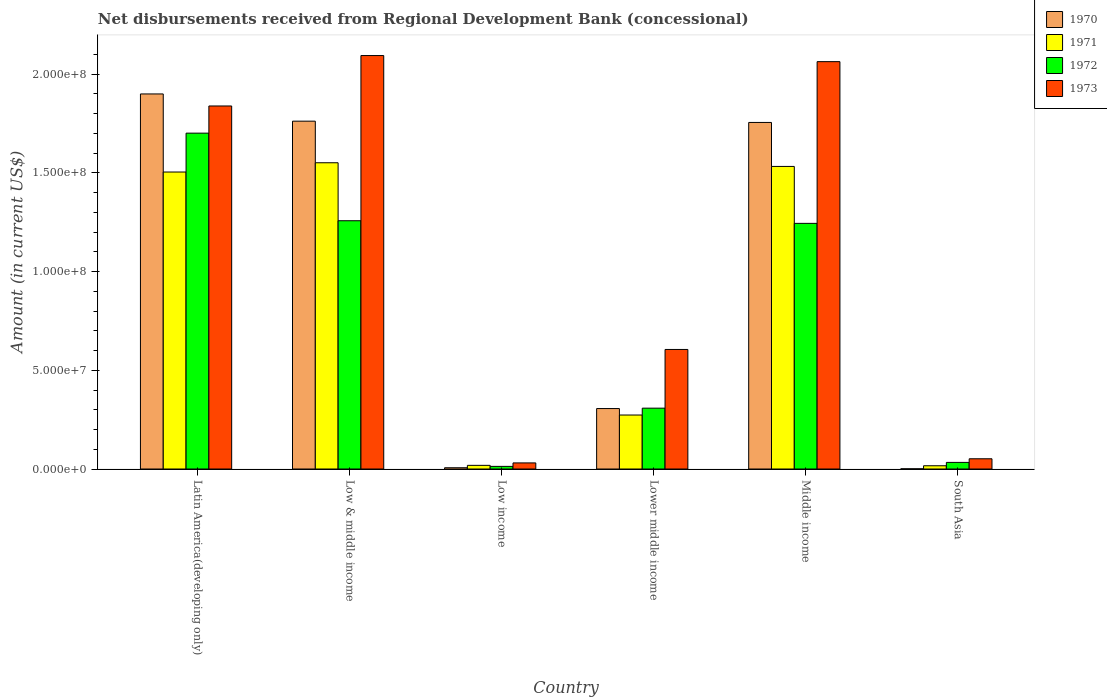How many different coloured bars are there?
Provide a succinct answer. 4. How many groups of bars are there?
Your response must be concise. 6. Are the number of bars per tick equal to the number of legend labels?
Your response must be concise. Yes. How many bars are there on the 6th tick from the left?
Keep it short and to the point. 4. How many bars are there on the 1st tick from the right?
Offer a very short reply. 4. What is the label of the 3rd group of bars from the left?
Offer a very short reply. Low income. In how many cases, is the number of bars for a given country not equal to the number of legend labels?
Ensure brevity in your answer.  0. What is the amount of disbursements received from Regional Development Bank in 1970 in Low income?
Keep it short and to the point. 6.47e+05. Across all countries, what is the maximum amount of disbursements received from Regional Development Bank in 1972?
Make the answer very short. 1.70e+08. Across all countries, what is the minimum amount of disbursements received from Regional Development Bank in 1970?
Your answer should be compact. 1.09e+05. In which country was the amount of disbursements received from Regional Development Bank in 1970 maximum?
Keep it short and to the point. Latin America(developing only). In which country was the amount of disbursements received from Regional Development Bank in 1972 minimum?
Your answer should be very brief. Low income. What is the total amount of disbursements received from Regional Development Bank in 1973 in the graph?
Keep it short and to the point. 6.69e+08. What is the difference between the amount of disbursements received from Regional Development Bank in 1972 in Latin America(developing only) and that in South Asia?
Provide a succinct answer. 1.67e+08. What is the difference between the amount of disbursements received from Regional Development Bank in 1970 in Middle income and the amount of disbursements received from Regional Development Bank in 1971 in Lower middle income?
Ensure brevity in your answer.  1.48e+08. What is the average amount of disbursements received from Regional Development Bank in 1970 per country?
Ensure brevity in your answer.  9.55e+07. What is the difference between the amount of disbursements received from Regional Development Bank of/in 1971 and amount of disbursements received from Regional Development Bank of/in 1970 in Lower middle income?
Offer a terse response. -3.27e+06. What is the ratio of the amount of disbursements received from Regional Development Bank in 1970 in Low income to that in South Asia?
Your answer should be compact. 5.94. Is the amount of disbursements received from Regional Development Bank in 1972 in Latin America(developing only) less than that in Low income?
Provide a short and direct response. No. What is the difference between the highest and the second highest amount of disbursements received from Regional Development Bank in 1972?
Your answer should be compact. 4.44e+07. What is the difference between the highest and the lowest amount of disbursements received from Regional Development Bank in 1970?
Your answer should be very brief. 1.90e+08. In how many countries, is the amount of disbursements received from Regional Development Bank in 1971 greater than the average amount of disbursements received from Regional Development Bank in 1971 taken over all countries?
Ensure brevity in your answer.  3. How many bars are there?
Give a very brief answer. 24. What is the difference between two consecutive major ticks on the Y-axis?
Your response must be concise. 5.00e+07. Are the values on the major ticks of Y-axis written in scientific E-notation?
Provide a succinct answer. Yes. Does the graph contain any zero values?
Provide a short and direct response. No. Does the graph contain grids?
Give a very brief answer. No. How are the legend labels stacked?
Make the answer very short. Vertical. What is the title of the graph?
Make the answer very short. Net disbursements received from Regional Development Bank (concessional). Does "2000" appear as one of the legend labels in the graph?
Your answer should be compact. No. What is the label or title of the X-axis?
Give a very brief answer. Country. What is the label or title of the Y-axis?
Give a very brief answer. Amount (in current US$). What is the Amount (in current US$) in 1970 in Latin America(developing only)?
Make the answer very short. 1.90e+08. What is the Amount (in current US$) in 1971 in Latin America(developing only)?
Your response must be concise. 1.50e+08. What is the Amount (in current US$) of 1972 in Latin America(developing only)?
Offer a terse response. 1.70e+08. What is the Amount (in current US$) of 1973 in Latin America(developing only)?
Ensure brevity in your answer.  1.84e+08. What is the Amount (in current US$) in 1970 in Low & middle income?
Offer a very short reply. 1.76e+08. What is the Amount (in current US$) of 1971 in Low & middle income?
Your answer should be very brief. 1.55e+08. What is the Amount (in current US$) of 1972 in Low & middle income?
Provide a succinct answer. 1.26e+08. What is the Amount (in current US$) in 1973 in Low & middle income?
Offer a very short reply. 2.09e+08. What is the Amount (in current US$) of 1970 in Low income?
Ensure brevity in your answer.  6.47e+05. What is the Amount (in current US$) of 1971 in Low income?
Ensure brevity in your answer.  1.86e+06. What is the Amount (in current US$) in 1972 in Low income?
Keep it short and to the point. 1.33e+06. What is the Amount (in current US$) in 1973 in Low income?
Your answer should be very brief. 3.09e+06. What is the Amount (in current US$) in 1970 in Lower middle income?
Offer a very short reply. 3.06e+07. What is the Amount (in current US$) of 1971 in Lower middle income?
Give a very brief answer. 2.74e+07. What is the Amount (in current US$) in 1972 in Lower middle income?
Your answer should be compact. 3.08e+07. What is the Amount (in current US$) in 1973 in Lower middle income?
Provide a short and direct response. 6.06e+07. What is the Amount (in current US$) of 1970 in Middle income?
Make the answer very short. 1.76e+08. What is the Amount (in current US$) of 1971 in Middle income?
Provide a short and direct response. 1.53e+08. What is the Amount (in current US$) of 1972 in Middle income?
Your response must be concise. 1.24e+08. What is the Amount (in current US$) of 1973 in Middle income?
Provide a short and direct response. 2.06e+08. What is the Amount (in current US$) of 1970 in South Asia?
Keep it short and to the point. 1.09e+05. What is the Amount (in current US$) in 1971 in South Asia?
Keep it short and to the point. 1.65e+06. What is the Amount (in current US$) of 1972 in South Asia?
Your response must be concise. 3.35e+06. What is the Amount (in current US$) in 1973 in South Asia?
Provide a succinct answer. 5.18e+06. Across all countries, what is the maximum Amount (in current US$) of 1970?
Provide a succinct answer. 1.90e+08. Across all countries, what is the maximum Amount (in current US$) of 1971?
Give a very brief answer. 1.55e+08. Across all countries, what is the maximum Amount (in current US$) of 1972?
Ensure brevity in your answer.  1.70e+08. Across all countries, what is the maximum Amount (in current US$) of 1973?
Offer a very short reply. 2.09e+08. Across all countries, what is the minimum Amount (in current US$) of 1970?
Your answer should be very brief. 1.09e+05. Across all countries, what is the minimum Amount (in current US$) in 1971?
Make the answer very short. 1.65e+06. Across all countries, what is the minimum Amount (in current US$) in 1972?
Keep it short and to the point. 1.33e+06. Across all countries, what is the minimum Amount (in current US$) in 1973?
Offer a very short reply. 3.09e+06. What is the total Amount (in current US$) of 1970 in the graph?
Ensure brevity in your answer.  5.73e+08. What is the total Amount (in current US$) in 1971 in the graph?
Offer a very short reply. 4.90e+08. What is the total Amount (in current US$) of 1972 in the graph?
Make the answer very short. 4.56e+08. What is the total Amount (in current US$) of 1973 in the graph?
Make the answer very short. 6.69e+08. What is the difference between the Amount (in current US$) in 1970 in Latin America(developing only) and that in Low & middle income?
Your answer should be very brief. 1.38e+07. What is the difference between the Amount (in current US$) in 1971 in Latin America(developing only) and that in Low & middle income?
Ensure brevity in your answer.  -4.69e+06. What is the difference between the Amount (in current US$) in 1972 in Latin America(developing only) and that in Low & middle income?
Ensure brevity in your answer.  4.44e+07. What is the difference between the Amount (in current US$) of 1973 in Latin America(developing only) and that in Low & middle income?
Your response must be concise. -2.55e+07. What is the difference between the Amount (in current US$) in 1970 in Latin America(developing only) and that in Low income?
Your answer should be compact. 1.89e+08. What is the difference between the Amount (in current US$) of 1971 in Latin America(developing only) and that in Low income?
Make the answer very short. 1.49e+08. What is the difference between the Amount (in current US$) in 1972 in Latin America(developing only) and that in Low income?
Your answer should be very brief. 1.69e+08. What is the difference between the Amount (in current US$) of 1973 in Latin America(developing only) and that in Low income?
Your answer should be compact. 1.81e+08. What is the difference between the Amount (in current US$) in 1970 in Latin America(developing only) and that in Lower middle income?
Your response must be concise. 1.59e+08. What is the difference between the Amount (in current US$) of 1971 in Latin America(developing only) and that in Lower middle income?
Offer a terse response. 1.23e+08. What is the difference between the Amount (in current US$) of 1972 in Latin America(developing only) and that in Lower middle income?
Give a very brief answer. 1.39e+08. What is the difference between the Amount (in current US$) of 1973 in Latin America(developing only) and that in Lower middle income?
Offer a very short reply. 1.23e+08. What is the difference between the Amount (in current US$) in 1970 in Latin America(developing only) and that in Middle income?
Give a very brief answer. 1.44e+07. What is the difference between the Amount (in current US$) in 1971 in Latin America(developing only) and that in Middle income?
Provide a short and direct response. -2.84e+06. What is the difference between the Amount (in current US$) of 1972 in Latin America(developing only) and that in Middle income?
Keep it short and to the point. 4.57e+07. What is the difference between the Amount (in current US$) in 1973 in Latin America(developing only) and that in Middle income?
Your answer should be compact. -2.25e+07. What is the difference between the Amount (in current US$) of 1970 in Latin America(developing only) and that in South Asia?
Give a very brief answer. 1.90e+08. What is the difference between the Amount (in current US$) in 1971 in Latin America(developing only) and that in South Asia?
Give a very brief answer. 1.49e+08. What is the difference between the Amount (in current US$) of 1972 in Latin America(developing only) and that in South Asia?
Give a very brief answer. 1.67e+08. What is the difference between the Amount (in current US$) in 1973 in Latin America(developing only) and that in South Asia?
Keep it short and to the point. 1.79e+08. What is the difference between the Amount (in current US$) of 1970 in Low & middle income and that in Low income?
Provide a succinct answer. 1.76e+08. What is the difference between the Amount (in current US$) of 1971 in Low & middle income and that in Low income?
Your response must be concise. 1.53e+08. What is the difference between the Amount (in current US$) of 1972 in Low & middle income and that in Low income?
Keep it short and to the point. 1.24e+08. What is the difference between the Amount (in current US$) of 1973 in Low & middle income and that in Low income?
Keep it short and to the point. 2.06e+08. What is the difference between the Amount (in current US$) of 1970 in Low & middle income and that in Lower middle income?
Offer a terse response. 1.46e+08. What is the difference between the Amount (in current US$) in 1971 in Low & middle income and that in Lower middle income?
Your answer should be compact. 1.28e+08. What is the difference between the Amount (in current US$) in 1972 in Low & middle income and that in Lower middle income?
Provide a succinct answer. 9.49e+07. What is the difference between the Amount (in current US$) in 1973 in Low & middle income and that in Lower middle income?
Ensure brevity in your answer.  1.49e+08. What is the difference between the Amount (in current US$) in 1970 in Low & middle income and that in Middle income?
Offer a very short reply. 6.47e+05. What is the difference between the Amount (in current US$) in 1971 in Low & middle income and that in Middle income?
Your response must be concise. 1.86e+06. What is the difference between the Amount (in current US$) in 1972 in Low & middle income and that in Middle income?
Keep it short and to the point. 1.33e+06. What is the difference between the Amount (in current US$) in 1973 in Low & middle income and that in Middle income?
Ensure brevity in your answer.  3.09e+06. What is the difference between the Amount (in current US$) in 1970 in Low & middle income and that in South Asia?
Make the answer very short. 1.76e+08. What is the difference between the Amount (in current US$) of 1971 in Low & middle income and that in South Asia?
Keep it short and to the point. 1.53e+08. What is the difference between the Amount (in current US$) of 1972 in Low & middle income and that in South Asia?
Offer a terse response. 1.22e+08. What is the difference between the Amount (in current US$) of 1973 in Low & middle income and that in South Asia?
Offer a very short reply. 2.04e+08. What is the difference between the Amount (in current US$) of 1970 in Low income and that in Lower middle income?
Offer a very short reply. -3.00e+07. What is the difference between the Amount (in current US$) in 1971 in Low income and that in Lower middle income?
Your answer should be very brief. -2.55e+07. What is the difference between the Amount (in current US$) of 1972 in Low income and that in Lower middle income?
Your response must be concise. -2.95e+07. What is the difference between the Amount (in current US$) of 1973 in Low income and that in Lower middle income?
Your answer should be compact. -5.75e+07. What is the difference between the Amount (in current US$) of 1970 in Low income and that in Middle income?
Offer a terse response. -1.75e+08. What is the difference between the Amount (in current US$) in 1971 in Low income and that in Middle income?
Keep it short and to the point. -1.51e+08. What is the difference between the Amount (in current US$) of 1972 in Low income and that in Middle income?
Offer a terse response. -1.23e+08. What is the difference between the Amount (in current US$) in 1973 in Low income and that in Middle income?
Provide a succinct answer. -2.03e+08. What is the difference between the Amount (in current US$) of 1970 in Low income and that in South Asia?
Offer a terse response. 5.38e+05. What is the difference between the Amount (in current US$) of 1971 in Low income and that in South Asia?
Offer a terse response. 2.09e+05. What is the difference between the Amount (in current US$) of 1972 in Low income and that in South Asia?
Provide a short and direct response. -2.02e+06. What is the difference between the Amount (in current US$) in 1973 in Low income and that in South Asia?
Provide a succinct answer. -2.09e+06. What is the difference between the Amount (in current US$) in 1970 in Lower middle income and that in Middle income?
Your response must be concise. -1.45e+08. What is the difference between the Amount (in current US$) in 1971 in Lower middle income and that in Middle income?
Your answer should be compact. -1.26e+08. What is the difference between the Amount (in current US$) of 1972 in Lower middle income and that in Middle income?
Offer a terse response. -9.36e+07. What is the difference between the Amount (in current US$) of 1973 in Lower middle income and that in Middle income?
Keep it short and to the point. -1.46e+08. What is the difference between the Amount (in current US$) of 1970 in Lower middle income and that in South Asia?
Your answer should be compact. 3.05e+07. What is the difference between the Amount (in current US$) in 1971 in Lower middle income and that in South Asia?
Ensure brevity in your answer.  2.57e+07. What is the difference between the Amount (in current US$) of 1972 in Lower middle income and that in South Asia?
Provide a short and direct response. 2.75e+07. What is the difference between the Amount (in current US$) of 1973 in Lower middle income and that in South Asia?
Give a very brief answer. 5.54e+07. What is the difference between the Amount (in current US$) in 1970 in Middle income and that in South Asia?
Keep it short and to the point. 1.75e+08. What is the difference between the Amount (in current US$) of 1971 in Middle income and that in South Asia?
Your answer should be very brief. 1.52e+08. What is the difference between the Amount (in current US$) of 1972 in Middle income and that in South Asia?
Offer a terse response. 1.21e+08. What is the difference between the Amount (in current US$) of 1973 in Middle income and that in South Asia?
Give a very brief answer. 2.01e+08. What is the difference between the Amount (in current US$) in 1970 in Latin America(developing only) and the Amount (in current US$) in 1971 in Low & middle income?
Offer a terse response. 3.49e+07. What is the difference between the Amount (in current US$) of 1970 in Latin America(developing only) and the Amount (in current US$) of 1972 in Low & middle income?
Your answer should be compact. 6.42e+07. What is the difference between the Amount (in current US$) of 1970 in Latin America(developing only) and the Amount (in current US$) of 1973 in Low & middle income?
Offer a terse response. -1.94e+07. What is the difference between the Amount (in current US$) of 1971 in Latin America(developing only) and the Amount (in current US$) of 1972 in Low & middle income?
Your answer should be very brief. 2.47e+07. What is the difference between the Amount (in current US$) in 1971 in Latin America(developing only) and the Amount (in current US$) in 1973 in Low & middle income?
Provide a succinct answer. -5.90e+07. What is the difference between the Amount (in current US$) of 1972 in Latin America(developing only) and the Amount (in current US$) of 1973 in Low & middle income?
Provide a short and direct response. -3.93e+07. What is the difference between the Amount (in current US$) in 1970 in Latin America(developing only) and the Amount (in current US$) in 1971 in Low income?
Your answer should be very brief. 1.88e+08. What is the difference between the Amount (in current US$) in 1970 in Latin America(developing only) and the Amount (in current US$) in 1972 in Low income?
Offer a very short reply. 1.89e+08. What is the difference between the Amount (in current US$) in 1970 in Latin America(developing only) and the Amount (in current US$) in 1973 in Low income?
Make the answer very short. 1.87e+08. What is the difference between the Amount (in current US$) of 1971 in Latin America(developing only) and the Amount (in current US$) of 1972 in Low income?
Give a very brief answer. 1.49e+08. What is the difference between the Amount (in current US$) in 1971 in Latin America(developing only) and the Amount (in current US$) in 1973 in Low income?
Make the answer very short. 1.47e+08. What is the difference between the Amount (in current US$) in 1972 in Latin America(developing only) and the Amount (in current US$) in 1973 in Low income?
Make the answer very short. 1.67e+08. What is the difference between the Amount (in current US$) in 1970 in Latin America(developing only) and the Amount (in current US$) in 1971 in Lower middle income?
Provide a short and direct response. 1.63e+08. What is the difference between the Amount (in current US$) in 1970 in Latin America(developing only) and the Amount (in current US$) in 1972 in Lower middle income?
Keep it short and to the point. 1.59e+08. What is the difference between the Amount (in current US$) of 1970 in Latin America(developing only) and the Amount (in current US$) of 1973 in Lower middle income?
Offer a terse response. 1.29e+08. What is the difference between the Amount (in current US$) of 1971 in Latin America(developing only) and the Amount (in current US$) of 1972 in Lower middle income?
Your response must be concise. 1.20e+08. What is the difference between the Amount (in current US$) of 1971 in Latin America(developing only) and the Amount (in current US$) of 1973 in Lower middle income?
Make the answer very short. 8.99e+07. What is the difference between the Amount (in current US$) in 1972 in Latin America(developing only) and the Amount (in current US$) in 1973 in Lower middle income?
Give a very brief answer. 1.10e+08. What is the difference between the Amount (in current US$) of 1970 in Latin America(developing only) and the Amount (in current US$) of 1971 in Middle income?
Offer a very short reply. 3.67e+07. What is the difference between the Amount (in current US$) of 1970 in Latin America(developing only) and the Amount (in current US$) of 1972 in Middle income?
Make the answer very short. 6.56e+07. What is the difference between the Amount (in current US$) in 1970 in Latin America(developing only) and the Amount (in current US$) in 1973 in Middle income?
Offer a very short reply. -1.64e+07. What is the difference between the Amount (in current US$) in 1971 in Latin America(developing only) and the Amount (in current US$) in 1972 in Middle income?
Keep it short and to the point. 2.60e+07. What is the difference between the Amount (in current US$) in 1971 in Latin America(developing only) and the Amount (in current US$) in 1973 in Middle income?
Your answer should be compact. -5.59e+07. What is the difference between the Amount (in current US$) in 1972 in Latin America(developing only) and the Amount (in current US$) in 1973 in Middle income?
Offer a terse response. -3.62e+07. What is the difference between the Amount (in current US$) in 1970 in Latin America(developing only) and the Amount (in current US$) in 1971 in South Asia?
Give a very brief answer. 1.88e+08. What is the difference between the Amount (in current US$) of 1970 in Latin America(developing only) and the Amount (in current US$) of 1972 in South Asia?
Ensure brevity in your answer.  1.87e+08. What is the difference between the Amount (in current US$) of 1970 in Latin America(developing only) and the Amount (in current US$) of 1973 in South Asia?
Keep it short and to the point. 1.85e+08. What is the difference between the Amount (in current US$) in 1971 in Latin America(developing only) and the Amount (in current US$) in 1972 in South Asia?
Your answer should be compact. 1.47e+08. What is the difference between the Amount (in current US$) in 1971 in Latin America(developing only) and the Amount (in current US$) in 1973 in South Asia?
Your answer should be compact. 1.45e+08. What is the difference between the Amount (in current US$) in 1972 in Latin America(developing only) and the Amount (in current US$) in 1973 in South Asia?
Make the answer very short. 1.65e+08. What is the difference between the Amount (in current US$) of 1970 in Low & middle income and the Amount (in current US$) of 1971 in Low income?
Offer a very short reply. 1.74e+08. What is the difference between the Amount (in current US$) in 1970 in Low & middle income and the Amount (in current US$) in 1972 in Low income?
Offer a very short reply. 1.75e+08. What is the difference between the Amount (in current US$) of 1970 in Low & middle income and the Amount (in current US$) of 1973 in Low income?
Provide a short and direct response. 1.73e+08. What is the difference between the Amount (in current US$) of 1971 in Low & middle income and the Amount (in current US$) of 1972 in Low income?
Your answer should be very brief. 1.54e+08. What is the difference between the Amount (in current US$) in 1971 in Low & middle income and the Amount (in current US$) in 1973 in Low income?
Provide a succinct answer. 1.52e+08. What is the difference between the Amount (in current US$) in 1972 in Low & middle income and the Amount (in current US$) in 1973 in Low income?
Your answer should be compact. 1.23e+08. What is the difference between the Amount (in current US$) of 1970 in Low & middle income and the Amount (in current US$) of 1971 in Lower middle income?
Offer a very short reply. 1.49e+08. What is the difference between the Amount (in current US$) in 1970 in Low & middle income and the Amount (in current US$) in 1972 in Lower middle income?
Give a very brief answer. 1.45e+08. What is the difference between the Amount (in current US$) of 1970 in Low & middle income and the Amount (in current US$) of 1973 in Lower middle income?
Your response must be concise. 1.16e+08. What is the difference between the Amount (in current US$) in 1971 in Low & middle income and the Amount (in current US$) in 1972 in Lower middle income?
Offer a terse response. 1.24e+08. What is the difference between the Amount (in current US$) of 1971 in Low & middle income and the Amount (in current US$) of 1973 in Lower middle income?
Make the answer very short. 9.46e+07. What is the difference between the Amount (in current US$) in 1972 in Low & middle income and the Amount (in current US$) in 1973 in Lower middle income?
Give a very brief answer. 6.52e+07. What is the difference between the Amount (in current US$) in 1970 in Low & middle income and the Amount (in current US$) in 1971 in Middle income?
Your answer should be very brief. 2.29e+07. What is the difference between the Amount (in current US$) of 1970 in Low & middle income and the Amount (in current US$) of 1972 in Middle income?
Offer a terse response. 5.18e+07. What is the difference between the Amount (in current US$) in 1970 in Low & middle income and the Amount (in current US$) in 1973 in Middle income?
Provide a succinct answer. -3.01e+07. What is the difference between the Amount (in current US$) of 1971 in Low & middle income and the Amount (in current US$) of 1972 in Middle income?
Make the answer very short. 3.07e+07. What is the difference between the Amount (in current US$) in 1971 in Low & middle income and the Amount (in current US$) in 1973 in Middle income?
Provide a succinct answer. -5.12e+07. What is the difference between the Amount (in current US$) of 1972 in Low & middle income and the Amount (in current US$) of 1973 in Middle income?
Keep it short and to the point. -8.06e+07. What is the difference between the Amount (in current US$) of 1970 in Low & middle income and the Amount (in current US$) of 1971 in South Asia?
Offer a terse response. 1.75e+08. What is the difference between the Amount (in current US$) of 1970 in Low & middle income and the Amount (in current US$) of 1972 in South Asia?
Offer a very short reply. 1.73e+08. What is the difference between the Amount (in current US$) of 1970 in Low & middle income and the Amount (in current US$) of 1973 in South Asia?
Keep it short and to the point. 1.71e+08. What is the difference between the Amount (in current US$) in 1971 in Low & middle income and the Amount (in current US$) in 1972 in South Asia?
Make the answer very short. 1.52e+08. What is the difference between the Amount (in current US$) of 1971 in Low & middle income and the Amount (in current US$) of 1973 in South Asia?
Your answer should be very brief. 1.50e+08. What is the difference between the Amount (in current US$) of 1972 in Low & middle income and the Amount (in current US$) of 1973 in South Asia?
Give a very brief answer. 1.21e+08. What is the difference between the Amount (in current US$) of 1970 in Low income and the Amount (in current US$) of 1971 in Lower middle income?
Make the answer very short. -2.67e+07. What is the difference between the Amount (in current US$) of 1970 in Low income and the Amount (in current US$) of 1972 in Lower middle income?
Provide a succinct answer. -3.02e+07. What is the difference between the Amount (in current US$) of 1970 in Low income and the Amount (in current US$) of 1973 in Lower middle income?
Provide a short and direct response. -5.99e+07. What is the difference between the Amount (in current US$) of 1971 in Low income and the Amount (in current US$) of 1972 in Lower middle income?
Offer a terse response. -2.90e+07. What is the difference between the Amount (in current US$) of 1971 in Low income and the Amount (in current US$) of 1973 in Lower middle income?
Offer a very short reply. -5.87e+07. What is the difference between the Amount (in current US$) of 1972 in Low income and the Amount (in current US$) of 1973 in Lower middle income?
Make the answer very short. -5.92e+07. What is the difference between the Amount (in current US$) in 1970 in Low income and the Amount (in current US$) in 1971 in Middle income?
Keep it short and to the point. -1.53e+08. What is the difference between the Amount (in current US$) of 1970 in Low income and the Amount (in current US$) of 1972 in Middle income?
Your response must be concise. -1.24e+08. What is the difference between the Amount (in current US$) of 1970 in Low income and the Amount (in current US$) of 1973 in Middle income?
Your response must be concise. -2.06e+08. What is the difference between the Amount (in current US$) in 1971 in Low income and the Amount (in current US$) in 1972 in Middle income?
Make the answer very short. -1.23e+08. What is the difference between the Amount (in current US$) of 1971 in Low income and the Amount (in current US$) of 1973 in Middle income?
Your answer should be very brief. -2.04e+08. What is the difference between the Amount (in current US$) in 1972 in Low income and the Amount (in current US$) in 1973 in Middle income?
Give a very brief answer. -2.05e+08. What is the difference between the Amount (in current US$) of 1970 in Low income and the Amount (in current US$) of 1971 in South Asia?
Your answer should be compact. -1.00e+06. What is the difference between the Amount (in current US$) in 1970 in Low income and the Amount (in current US$) in 1972 in South Asia?
Give a very brief answer. -2.70e+06. What is the difference between the Amount (in current US$) in 1970 in Low income and the Amount (in current US$) in 1973 in South Asia?
Offer a very short reply. -4.54e+06. What is the difference between the Amount (in current US$) of 1971 in Low income and the Amount (in current US$) of 1972 in South Asia?
Your response must be concise. -1.49e+06. What is the difference between the Amount (in current US$) in 1971 in Low income and the Amount (in current US$) in 1973 in South Asia?
Ensure brevity in your answer.  -3.32e+06. What is the difference between the Amount (in current US$) of 1972 in Low income and the Amount (in current US$) of 1973 in South Asia?
Make the answer very short. -3.85e+06. What is the difference between the Amount (in current US$) in 1970 in Lower middle income and the Amount (in current US$) in 1971 in Middle income?
Keep it short and to the point. -1.23e+08. What is the difference between the Amount (in current US$) of 1970 in Lower middle income and the Amount (in current US$) of 1972 in Middle income?
Keep it short and to the point. -9.38e+07. What is the difference between the Amount (in current US$) in 1970 in Lower middle income and the Amount (in current US$) in 1973 in Middle income?
Make the answer very short. -1.76e+08. What is the difference between the Amount (in current US$) of 1971 in Lower middle income and the Amount (in current US$) of 1972 in Middle income?
Ensure brevity in your answer.  -9.71e+07. What is the difference between the Amount (in current US$) in 1971 in Lower middle income and the Amount (in current US$) in 1973 in Middle income?
Ensure brevity in your answer.  -1.79e+08. What is the difference between the Amount (in current US$) of 1972 in Lower middle income and the Amount (in current US$) of 1973 in Middle income?
Offer a terse response. -1.76e+08. What is the difference between the Amount (in current US$) in 1970 in Lower middle income and the Amount (in current US$) in 1971 in South Asia?
Offer a terse response. 2.90e+07. What is the difference between the Amount (in current US$) in 1970 in Lower middle income and the Amount (in current US$) in 1972 in South Asia?
Offer a terse response. 2.73e+07. What is the difference between the Amount (in current US$) in 1970 in Lower middle income and the Amount (in current US$) in 1973 in South Asia?
Offer a very short reply. 2.54e+07. What is the difference between the Amount (in current US$) in 1971 in Lower middle income and the Amount (in current US$) in 1972 in South Asia?
Make the answer very short. 2.40e+07. What is the difference between the Amount (in current US$) in 1971 in Lower middle income and the Amount (in current US$) in 1973 in South Asia?
Your answer should be compact. 2.22e+07. What is the difference between the Amount (in current US$) in 1972 in Lower middle income and the Amount (in current US$) in 1973 in South Asia?
Your response must be concise. 2.56e+07. What is the difference between the Amount (in current US$) in 1970 in Middle income and the Amount (in current US$) in 1971 in South Asia?
Offer a terse response. 1.74e+08. What is the difference between the Amount (in current US$) of 1970 in Middle income and the Amount (in current US$) of 1972 in South Asia?
Provide a short and direct response. 1.72e+08. What is the difference between the Amount (in current US$) in 1970 in Middle income and the Amount (in current US$) in 1973 in South Asia?
Give a very brief answer. 1.70e+08. What is the difference between the Amount (in current US$) of 1971 in Middle income and the Amount (in current US$) of 1972 in South Asia?
Ensure brevity in your answer.  1.50e+08. What is the difference between the Amount (in current US$) in 1971 in Middle income and the Amount (in current US$) in 1973 in South Asia?
Keep it short and to the point. 1.48e+08. What is the difference between the Amount (in current US$) of 1972 in Middle income and the Amount (in current US$) of 1973 in South Asia?
Provide a succinct answer. 1.19e+08. What is the average Amount (in current US$) of 1970 per country?
Provide a succinct answer. 9.55e+07. What is the average Amount (in current US$) of 1971 per country?
Your response must be concise. 8.16e+07. What is the average Amount (in current US$) in 1972 per country?
Keep it short and to the point. 7.60e+07. What is the average Amount (in current US$) of 1973 per country?
Your answer should be very brief. 1.11e+08. What is the difference between the Amount (in current US$) in 1970 and Amount (in current US$) in 1971 in Latin America(developing only)?
Ensure brevity in your answer.  3.96e+07. What is the difference between the Amount (in current US$) of 1970 and Amount (in current US$) of 1972 in Latin America(developing only)?
Make the answer very short. 1.99e+07. What is the difference between the Amount (in current US$) in 1970 and Amount (in current US$) in 1973 in Latin America(developing only)?
Make the answer very short. 6.10e+06. What is the difference between the Amount (in current US$) of 1971 and Amount (in current US$) of 1972 in Latin America(developing only)?
Your answer should be very brief. -1.97e+07. What is the difference between the Amount (in current US$) of 1971 and Amount (in current US$) of 1973 in Latin America(developing only)?
Offer a very short reply. -3.35e+07. What is the difference between the Amount (in current US$) in 1972 and Amount (in current US$) in 1973 in Latin America(developing only)?
Provide a short and direct response. -1.38e+07. What is the difference between the Amount (in current US$) in 1970 and Amount (in current US$) in 1971 in Low & middle income?
Your answer should be compact. 2.11e+07. What is the difference between the Amount (in current US$) in 1970 and Amount (in current US$) in 1972 in Low & middle income?
Your response must be concise. 5.04e+07. What is the difference between the Amount (in current US$) in 1970 and Amount (in current US$) in 1973 in Low & middle income?
Provide a short and direct response. -3.32e+07. What is the difference between the Amount (in current US$) of 1971 and Amount (in current US$) of 1972 in Low & middle income?
Your answer should be very brief. 2.94e+07. What is the difference between the Amount (in current US$) in 1971 and Amount (in current US$) in 1973 in Low & middle income?
Your answer should be compact. -5.43e+07. What is the difference between the Amount (in current US$) in 1972 and Amount (in current US$) in 1973 in Low & middle income?
Your answer should be very brief. -8.37e+07. What is the difference between the Amount (in current US$) in 1970 and Amount (in current US$) in 1971 in Low income?
Give a very brief answer. -1.21e+06. What is the difference between the Amount (in current US$) of 1970 and Amount (in current US$) of 1972 in Low income?
Your answer should be compact. -6.86e+05. What is the difference between the Amount (in current US$) in 1970 and Amount (in current US$) in 1973 in Low income?
Your answer should be very brief. -2.44e+06. What is the difference between the Amount (in current US$) in 1971 and Amount (in current US$) in 1972 in Low income?
Keep it short and to the point. 5.26e+05. What is the difference between the Amount (in current US$) of 1971 and Amount (in current US$) of 1973 in Low income?
Offer a terse response. -1.23e+06. What is the difference between the Amount (in current US$) of 1972 and Amount (in current US$) of 1973 in Low income?
Your response must be concise. -1.76e+06. What is the difference between the Amount (in current US$) of 1970 and Amount (in current US$) of 1971 in Lower middle income?
Your answer should be very brief. 3.27e+06. What is the difference between the Amount (in current US$) of 1970 and Amount (in current US$) of 1972 in Lower middle income?
Make the answer very short. -2.02e+05. What is the difference between the Amount (in current US$) in 1970 and Amount (in current US$) in 1973 in Lower middle income?
Keep it short and to the point. -2.99e+07. What is the difference between the Amount (in current US$) in 1971 and Amount (in current US$) in 1972 in Lower middle income?
Give a very brief answer. -3.47e+06. What is the difference between the Amount (in current US$) in 1971 and Amount (in current US$) in 1973 in Lower middle income?
Keep it short and to the point. -3.32e+07. What is the difference between the Amount (in current US$) in 1972 and Amount (in current US$) in 1973 in Lower middle income?
Ensure brevity in your answer.  -2.97e+07. What is the difference between the Amount (in current US$) in 1970 and Amount (in current US$) in 1971 in Middle income?
Your answer should be very brief. 2.23e+07. What is the difference between the Amount (in current US$) of 1970 and Amount (in current US$) of 1972 in Middle income?
Ensure brevity in your answer.  5.11e+07. What is the difference between the Amount (in current US$) of 1970 and Amount (in current US$) of 1973 in Middle income?
Make the answer very short. -3.08e+07. What is the difference between the Amount (in current US$) of 1971 and Amount (in current US$) of 1972 in Middle income?
Make the answer very short. 2.88e+07. What is the difference between the Amount (in current US$) in 1971 and Amount (in current US$) in 1973 in Middle income?
Keep it short and to the point. -5.31e+07. What is the difference between the Amount (in current US$) of 1972 and Amount (in current US$) of 1973 in Middle income?
Offer a terse response. -8.19e+07. What is the difference between the Amount (in current US$) in 1970 and Amount (in current US$) in 1971 in South Asia?
Make the answer very short. -1.54e+06. What is the difference between the Amount (in current US$) of 1970 and Amount (in current US$) of 1972 in South Asia?
Provide a short and direct response. -3.24e+06. What is the difference between the Amount (in current US$) of 1970 and Amount (in current US$) of 1973 in South Asia?
Offer a very short reply. -5.08e+06. What is the difference between the Amount (in current US$) of 1971 and Amount (in current US$) of 1972 in South Asia?
Make the answer very short. -1.70e+06. What is the difference between the Amount (in current US$) of 1971 and Amount (in current US$) of 1973 in South Asia?
Your response must be concise. -3.53e+06. What is the difference between the Amount (in current US$) in 1972 and Amount (in current US$) in 1973 in South Asia?
Give a very brief answer. -1.83e+06. What is the ratio of the Amount (in current US$) of 1970 in Latin America(developing only) to that in Low & middle income?
Offer a very short reply. 1.08. What is the ratio of the Amount (in current US$) of 1971 in Latin America(developing only) to that in Low & middle income?
Your answer should be compact. 0.97. What is the ratio of the Amount (in current US$) in 1972 in Latin America(developing only) to that in Low & middle income?
Your answer should be very brief. 1.35. What is the ratio of the Amount (in current US$) in 1973 in Latin America(developing only) to that in Low & middle income?
Give a very brief answer. 0.88. What is the ratio of the Amount (in current US$) of 1970 in Latin America(developing only) to that in Low income?
Offer a very short reply. 293.65. What is the ratio of the Amount (in current US$) in 1971 in Latin America(developing only) to that in Low income?
Provide a short and direct response. 80.93. What is the ratio of the Amount (in current US$) of 1972 in Latin America(developing only) to that in Low income?
Your answer should be compact. 127.63. What is the ratio of the Amount (in current US$) of 1973 in Latin America(developing only) to that in Low income?
Offer a very short reply. 59.49. What is the ratio of the Amount (in current US$) in 1970 in Latin America(developing only) to that in Lower middle income?
Keep it short and to the point. 6.2. What is the ratio of the Amount (in current US$) in 1971 in Latin America(developing only) to that in Lower middle income?
Provide a succinct answer. 5.5. What is the ratio of the Amount (in current US$) of 1972 in Latin America(developing only) to that in Lower middle income?
Ensure brevity in your answer.  5.52. What is the ratio of the Amount (in current US$) of 1973 in Latin America(developing only) to that in Lower middle income?
Give a very brief answer. 3.04. What is the ratio of the Amount (in current US$) of 1970 in Latin America(developing only) to that in Middle income?
Make the answer very short. 1.08. What is the ratio of the Amount (in current US$) in 1971 in Latin America(developing only) to that in Middle income?
Provide a short and direct response. 0.98. What is the ratio of the Amount (in current US$) in 1972 in Latin America(developing only) to that in Middle income?
Give a very brief answer. 1.37. What is the ratio of the Amount (in current US$) in 1973 in Latin America(developing only) to that in Middle income?
Offer a terse response. 0.89. What is the ratio of the Amount (in current US$) in 1970 in Latin America(developing only) to that in South Asia?
Make the answer very short. 1743.04. What is the ratio of the Amount (in current US$) in 1971 in Latin America(developing only) to that in South Asia?
Make the answer very short. 91.18. What is the ratio of the Amount (in current US$) in 1972 in Latin America(developing only) to that in South Asia?
Offer a very short reply. 50.78. What is the ratio of the Amount (in current US$) in 1973 in Latin America(developing only) to that in South Asia?
Your answer should be compact. 35.47. What is the ratio of the Amount (in current US$) of 1970 in Low & middle income to that in Low income?
Ensure brevity in your answer.  272.33. What is the ratio of the Amount (in current US$) of 1971 in Low & middle income to that in Low income?
Keep it short and to the point. 83.45. What is the ratio of the Amount (in current US$) of 1972 in Low & middle income to that in Low income?
Your response must be concise. 94.35. What is the ratio of the Amount (in current US$) of 1973 in Low & middle income to that in Low income?
Provide a short and direct response. 67.76. What is the ratio of the Amount (in current US$) in 1970 in Low & middle income to that in Lower middle income?
Keep it short and to the point. 5.75. What is the ratio of the Amount (in current US$) in 1971 in Low & middle income to that in Lower middle income?
Offer a very short reply. 5.67. What is the ratio of the Amount (in current US$) of 1972 in Low & middle income to that in Lower middle income?
Offer a very short reply. 4.08. What is the ratio of the Amount (in current US$) of 1973 in Low & middle income to that in Lower middle income?
Make the answer very short. 3.46. What is the ratio of the Amount (in current US$) in 1970 in Low & middle income to that in Middle income?
Make the answer very short. 1. What is the ratio of the Amount (in current US$) in 1971 in Low & middle income to that in Middle income?
Your answer should be compact. 1.01. What is the ratio of the Amount (in current US$) in 1972 in Low & middle income to that in Middle income?
Provide a succinct answer. 1.01. What is the ratio of the Amount (in current US$) in 1973 in Low & middle income to that in Middle income?
Your answer should be compact. 1.01. What is the ratio of the Amount (in current US$) in 1970 in Low & middle income to that in South Asia?
Provide a succinct answer. 1616.51. What is the ratio of the Amount (in current US$) of 1971 in Low & middle income to that in South Asia?
Offer a terse response. 94.02. What is the ratio of the Amount (in current US$) in 1972 in Low & middle income to that in South Asia?
Provide a succinct answer. 37.54. What is the ratio of the Amount (in current US$) of 1973 in Low & middle income to that in South Asia?
Your answer should be compact. 40.4. What is the ratio of the Amount (in current US$) in 1970 in Low income to that in Lower middle income?
Offer a very short reply. 0.02. What is the ratio of the Amount (in current US$) in 1971 in Low income to that in Lower middle income?
Make the answer very short. 0.07. What is the ratio of the Amount (in current US$) in 1972 in Low income to that in Lower middle income?
Offer a terse response. 0.04. What is the ratio of the Amount (in current US$) in 1973 in Low income to that in Lower middle income?
Provide a short and direct response. 0.05. What is the ratio of the Amount (in current US$) in 1970 in Low income to that in Middle income?
Give a very brief answer. 0. What is the ratio of the Amount (in current US$) in 1971 in Low income to that in Middle income?
Offer a very short reply. 0.01. What is the ratio of the Amount (in current US$) of 1972 in Low income to that in Middle income?
Keep it short and to the point. 0.01. What is the ratio of the Amount (in current US$) of 1973 in Low income to that in Middle income?
Your answer should be very brief. 0.01. What is the ratio of the Amount (in current US$) of 1970 in Low income to that in South Asia?
Your response must be concise. 5.94. What is the ratio of the Amount (in current US$) of 1971 in Low income to that in South Asia?
Give a very brief answer. 1.13. What is the ratio of the Amount (in current US$) in 1972 in Low income to that in South Asia?
Provide a succinct answer. 0.4. What is the ratio of the Amount (in current US$) in 1973 in Low income to that in South Asia?
Make the answer very short. 0.6. What is the ratio of the Amount (in current US$) of 1970 in Lower middle income to that in Middle income?
Provide a short and direct response. 0.17. What is the ratio of the Amount (in current US$) in 1971 in Lower middle income to that in Middle income?
Your response must be concise. 0.18. What is the ratio of the Amount (in current US$) in 1972 in Lower middle income to that in Middle income?
Your response must be concise. 0.25. What is the ratio of the Amount (in current US$) in 1973 in Lower middle income to that in Middle income?
Make the answer very short. 0.29. What is the ratio of the Amount (in current US$) of 1970 in Lower middle income to that in South Asia?
Ensure brevity in your answer.  280.94. What is the ratio of the Amount (in current US$) in 1971 in Lower middle income to that in South Asia?
Offer a very short reply. 16.58. What is the ratio of the Amount (in current US$) in 1972 in Lower middle income to that in South Asia?
Provide a short and direct response. 9.2. What is the ratio of the Amount (in current US$) of 1973 in Lower middle income to that in South Asia?
Keep it short and to the point. 11.68. What is the ratio of the Amount (in current US$) in 1970 in Middle income to that in South Asia?
Offer a terse response. 1610.58. What is the ratio of the Amount (in current US$) of 1971 in Middle income to that in South Asia?
Your answer should be very brief. 92.89. What is the ratio of the Amount (in current US$) of 1972 in Middle income to that in South Asia?
Keep it short and to the point. 37.14. What is the ratio of the Amount (in current US$) in 1973 in Middle income to that in South Asia?
Offer a terse response. 39.8. What is the difference between the highest and the second highest Amount (in current US$) in 1970?
Provide a succinct answer. 1.38e+07. What is the difference between the highest and the second highest Amount (in current US$) of 1971?
Offer a very short reply. 1.86e+06. What is the difference between the highest and the second highest Amount (in current US$) in 1972?
Offer a terse response. 4.44e+07. What is the difference between the highest and the second highest Amount (in current US$) of 1973?
Provide a short and direct response. 3.09e+06. What is the difference between the highest and the lowest Amount (in current US$) in 1970?
Offer a very short reply. 1.90e+08. What is the difference between the highest and the lowest Amount (in current US$) in 1971?
Provide a succinct answer. 1.53e+08. What is the difference between the highest and the lowest Amount (in current US$) of 1972?
Offer a terse response. 1.69e+08. What is the difference between the highest and the lowest Amount (in current US$) in 1973?
Provide a short and direct response. 2.06e+08. 